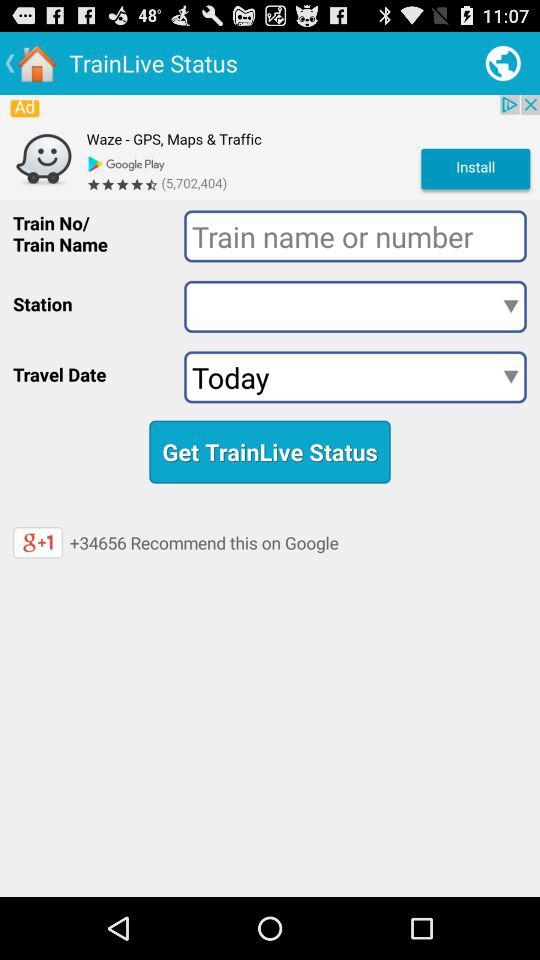How many people have recommended it on "Google"? On "Google", +34656 people have recommended it. 